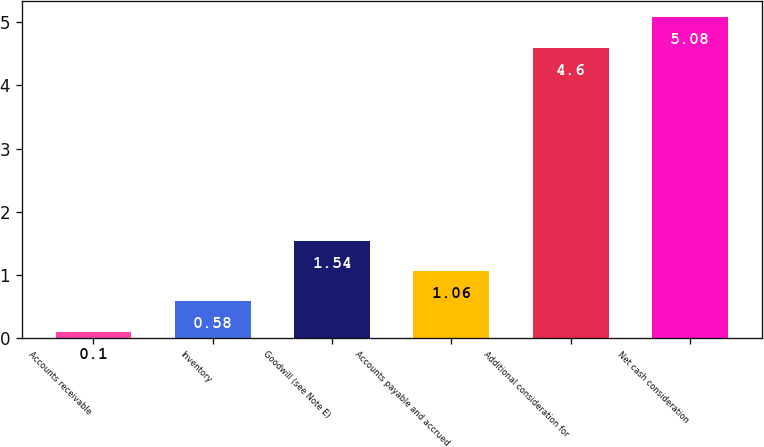Convert chart. <chart><loc_0><loc_0><loc_500><loc_500><bar_chart><fcel>Accounts receivable<fcel>Inventory<fcel>Goodwill (see Note E)<fcel>Accounts payable and accrued<fcel>Additional consideration for<fcel>Net cash consideration<nl><fcel>0.1<fcel>0.58<fcel>1.54<fcel>1.06<fcel>4.6<fcel>5.08<nl></chart> 